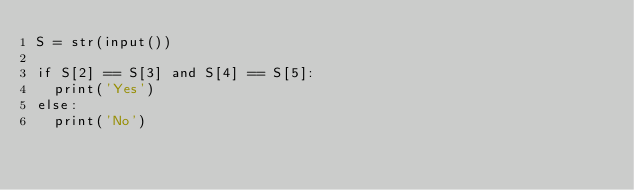<code> <loc_0><loc_0><loc_500><loc_500><_Python_>S = str(input())

if S[2] == S[3] and S[4] == S[5]:
  print('Yes')
else:
  print('No')</code> 